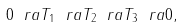Convert formula to latex. <formula><loc_0><loc_0><loc_500><loc_500>0 \ r a T _ { 1 } \ r a T _ { 2 } \ r a T _ { 3 } \ r a 0 ,</formula> 